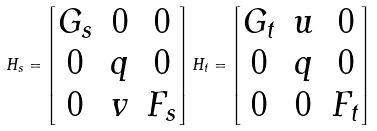Convert formula to latex. <formula><loc_0><loc_0><loc_500><loc_500>H _ { s } = \begin{bmatrix} G _ { s } & 0 & 0 \\ 0 & q & 0 \\ 0 & v & F _ { s } \end{bmatrix} H _ { t } = \begin{bmatrix} G _ { t } & u & 0 \\ 0 & q & 0 \\ 0 & 0 & F _ { t } \end{bmatrix}</formula> 